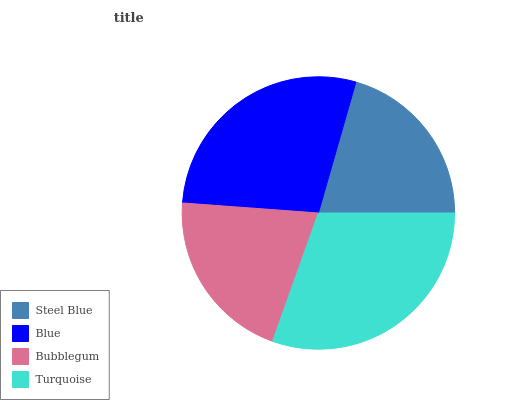Is Steel Blue the minimum?
Answer yes or no. Yes. Is Turquoise the maximum?
Answer yes or no. Yes. Is Blue the minimum?
Answer yes or no. No. Is Blue the maximum?
Answer yes or no. No. Is Blue greater than Steel Blue?
Answer yes or no. Yes. Is Steel Blue less than Blue?
Answer yes or no. Yes. Is Steel Blue greater than Blue?
Answer yes or no. No. Is Blue less than Steel Blue?
Answer yes or no. No. Is Blue the high median?
Answer yes or no. Yes. Is Bubblegum the low median?
Answer yes or no. Yes. Is Turquoise the high median?
Answer yes or no. No. Is Turquoise the low median?
Answer yes or no. No. 